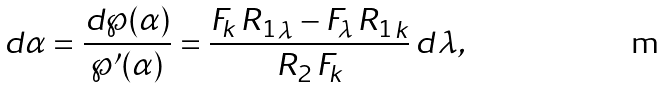<formula> <loc_0><loc_0><loc_500><loc_500>d \alpha = \frac { d \wp ( \alpha ) } { \wp ^ { \prime } ( \alpha ) } = \frac { F _ { k } \, { R _ { 1 } } _ { \lambda } - F _ { \lambda } \, { R _ { 1 } } _ { k } } { R _ { 2 } \, F _ { k } } \, d \lambda ,</formula> 